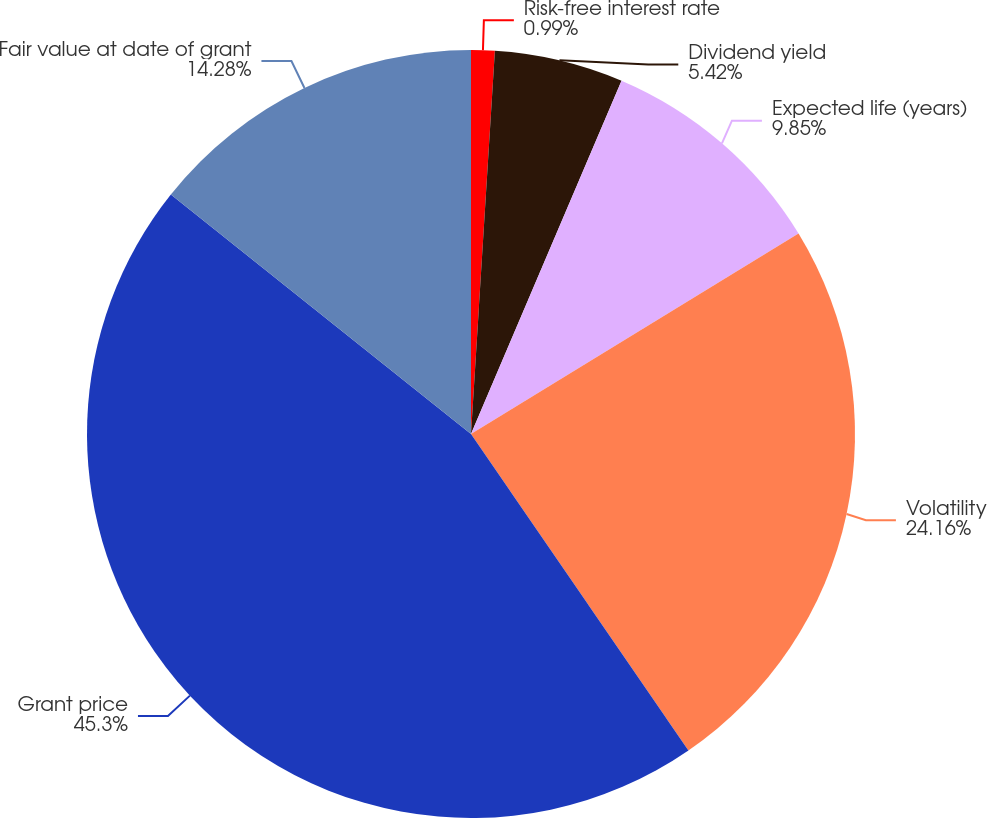<chart> <loc_0><loc_0><loc_500><loc_500><pie_chart><fcel>Risk-free interest rate<fcel>Dividend yield<fcel>Expected life (years)<fcel>Volatility<fcel>Grant price<fcel>Fair value at date of grant<nl><fcel>0.99%<fcel>5.42%<fcel>9.85%<fcel>24.16%<fcel>45.3%<fcel>14.28%<nl></chart> 